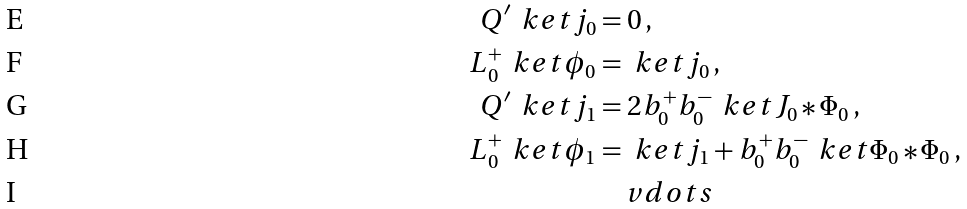<formula> <loc_0><loc_0><loc_500><loc_500>Q ^ { \prime } \, \ k e t { j _ { 0 } } & = 0 \, , \\ L _ { 0 } ^ { + } \, \ k e t { \phi _ { 0 } } & = \ k e t { j _ { 0 } } \, , \\ Q ^ { \prime } \, \ k e t { j _ { 1 } } & = 2 b _ { 0 } ^ { + } b _ { 0 } ^ { - } \, \ k e t { J _ { 0 } * \Phi _ { 0 } } \, , \\ L _ { 0 } ^ { + } \, \ k e t { \phi _ { 1 } } & = \ k e t { j _ { 1 } } + b _ { 0 } ^ { + } b _ { 0 } ^ { - } \, \ k e t { \Phi _ { 0 } * \Phi _ { 0 } } \, , \\ & \quad v d o t s</formula> 